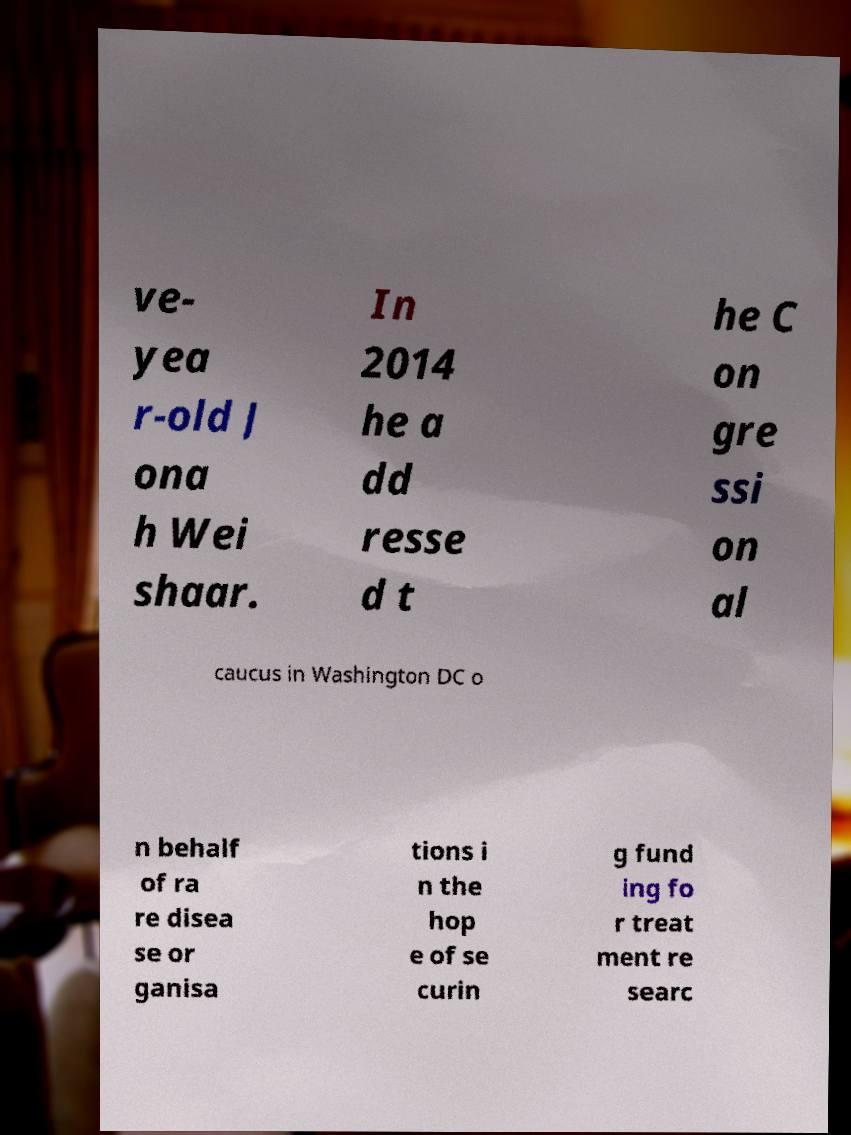There's text embedded in this image that I need extracted. Can you transcribe it verbatim? ve- yea r-old J ona h Wei shaar. In 2014 he a dd resse d t he C on gre ssi on al caucus in Washington DC o n behalf of ra re disea se or ganisa tions i n the hop e of se curin g fund ing fo r treat ment re searc 